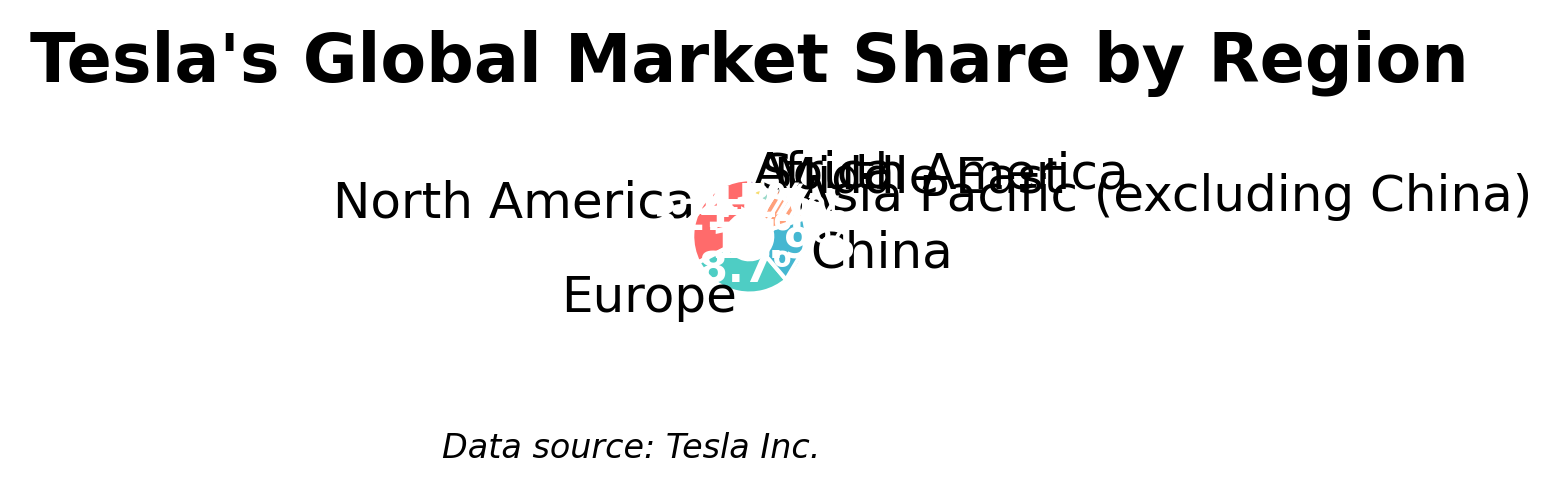How much bigger is Tesla's market share in Europe compared to South America? To find how much bigger Tesla's market share is in Europe compared to South America, subtract South America's market share (2.8%) from Europe's market share (28.7%). 28.7 - 2.8 = 25.9
Answer: 25.9% What's the combined market share of Europe and China regions? To find the combined market share of Europe and China regions, sum their market shares: 28.7% from Europe and 18.9% from China. 28.7 + 18.9 = 47.6
Answer: 47.6% Which region has the smallest market share, and what is its value? By examining the pie chart, it can be seen that Africa has the smallest market share, which is represented as 1.5%.
Answer: Africa, 1.5% What is the total market share of the regions excluding North America and Europe? To find the total market share of the regions excluding North America and Europe, sum the market shares of China, Asia Pacific (excluding China), Middle East, South America, and Africa. 18.9 + 11.4 + 4.2 + 2.8 + 1.5 = 38.8
Answer: 38.8% Which region has a slightly higher market share, Middle East or South America? By looking at the values on the pie chart, the Middle East has a slightly higher market share (4.2%) compared to South America (2.8%).
Answer: Middle East What is the difference in market share between the region with the largest and smallest shares? North America has the largest market share at 32.5%, and Africa has the smallest market share at 1.5%. Subtract the smallest from the largest: 32.5 - 1.5 = 31
Answer: 31% How much more market share does North America have compared to Asia Pacific (excluding China)? Subtract Asia Pacific's share (11.4%) from North America's share (32.5%): 32.5 - 11.4 = 21.1
Answer: 21.1% If you combine the market shares of Middle East and South America, is it greater than the share of China? Add the market shares of Middle East (4.2%) and South America (2.8%): 4.2 + 2.8 = 7.0. Since 7.0 is less than China's market share of 18.9%, the combined share is not greater.
Answer: No What percentage of the market is covered by the top three regions with the highest shares? The top three regions with the highest shares are North America (32.5%), Europe (28.7%), and China (18.9%). Sum these values: 32.5 + 28.7 + 18.9 = 80.1
Answer: 80.1% In the pie chart, which region's wedge is represented by a light blue color, and what is its market share? By looking at the color, the region represented by the light blue wedge is Asia Pacific (excluding China), which has a market share of 11.4%.
Answer: Asia Pacific (excluding China), 11.4% 